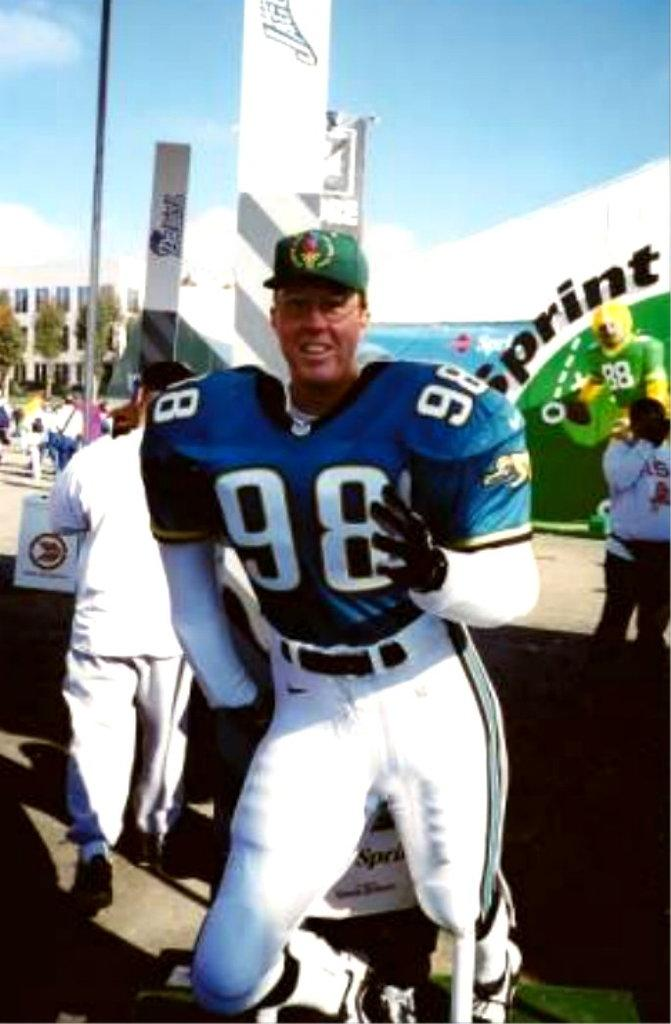<image>
Relay a brief, clear account of the picture shown. Player number 98 is wearing a green baseball hat with his football uniform. 